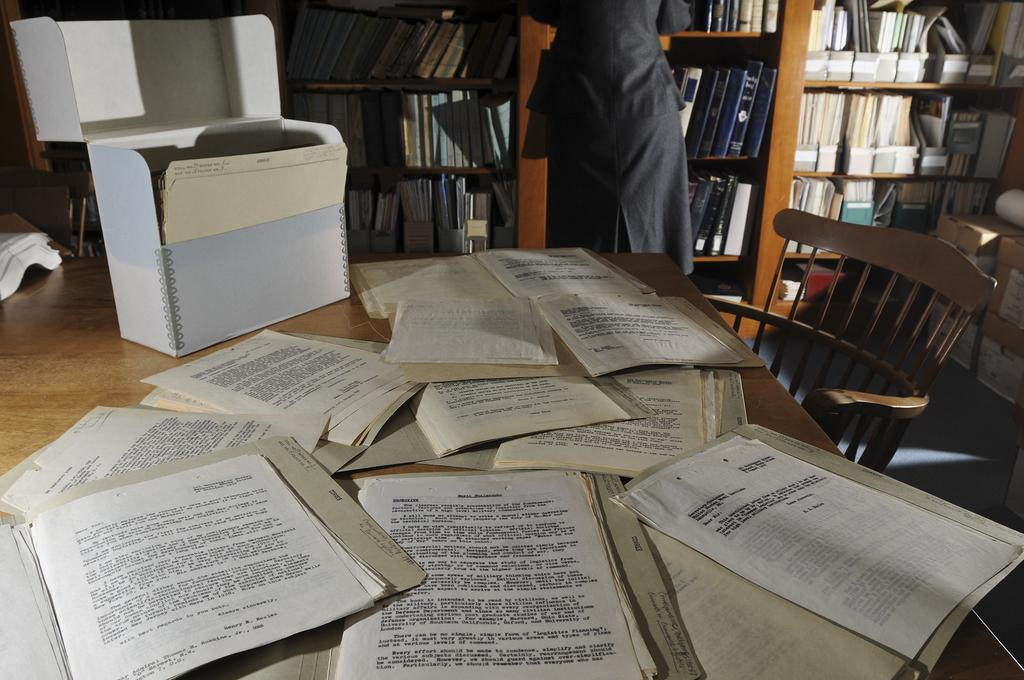What objects are on the table in the image? There are papers and a box on the table in the image. What piece of furniture is in front of the table? There is a chair in front of the table. What is the woman doing in the image? The woman is standing in front of a bookshelf. What type of bean is being discussed in the image? There is no bean present in the image, and therefore no discussion about beans can be observed. 